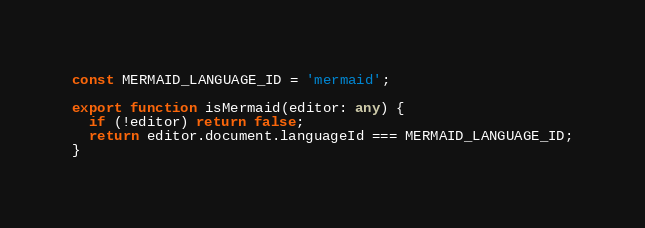Convert code to text. <code><loc_0><loc_0><loc_500><loc_500><_TypeScript_>const MERMAID_LANGUAGE_ID = 'mermaid';

export function isMermaid(editor: any) {
  if (!editor) return false;
  return editor.document.languageId === MERMAID_LANGUAGE_ID;
}
</code> 